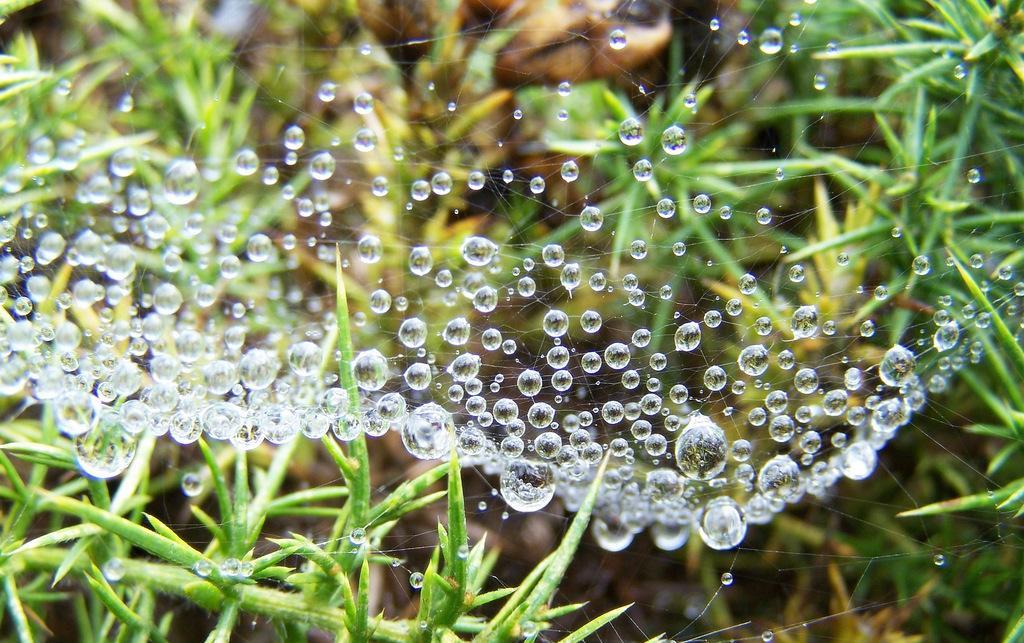Please provide a concise description of this image. In the image we can see there are water droplets on the spider web and there are plants. Behind the image is blurred. 